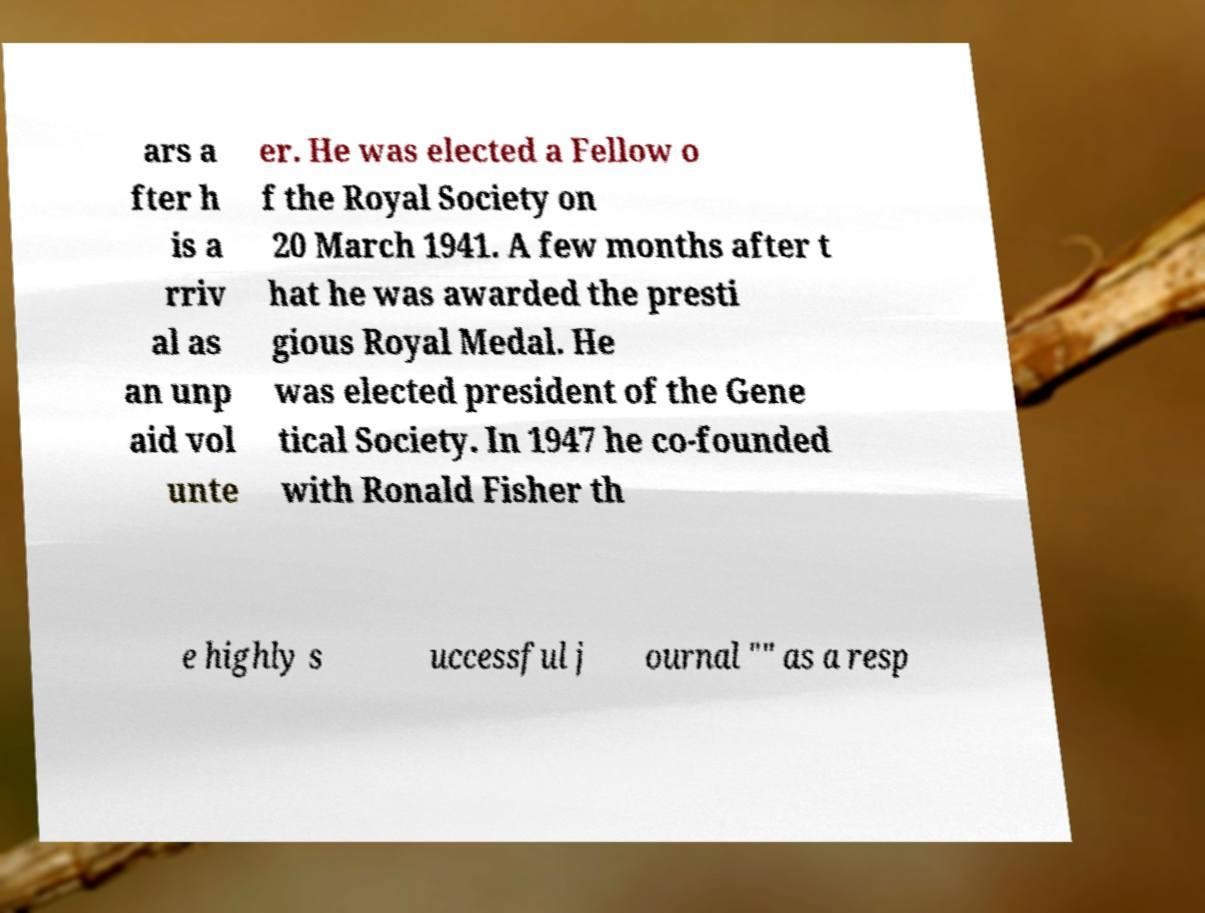Could you extract and type out the text from this image? ars a fter h is a rriv al as an unp aid vol unte er. He was elected a Fellow o f the Royal Society on 20 March 1941. A few months after t hat he was awarded the presti gious Royal Medal. He was elected president of the Gene tical Society. In 1947 he co-founded with Ronald Fisher th e highly s uccessful j ournal "" as a resp 